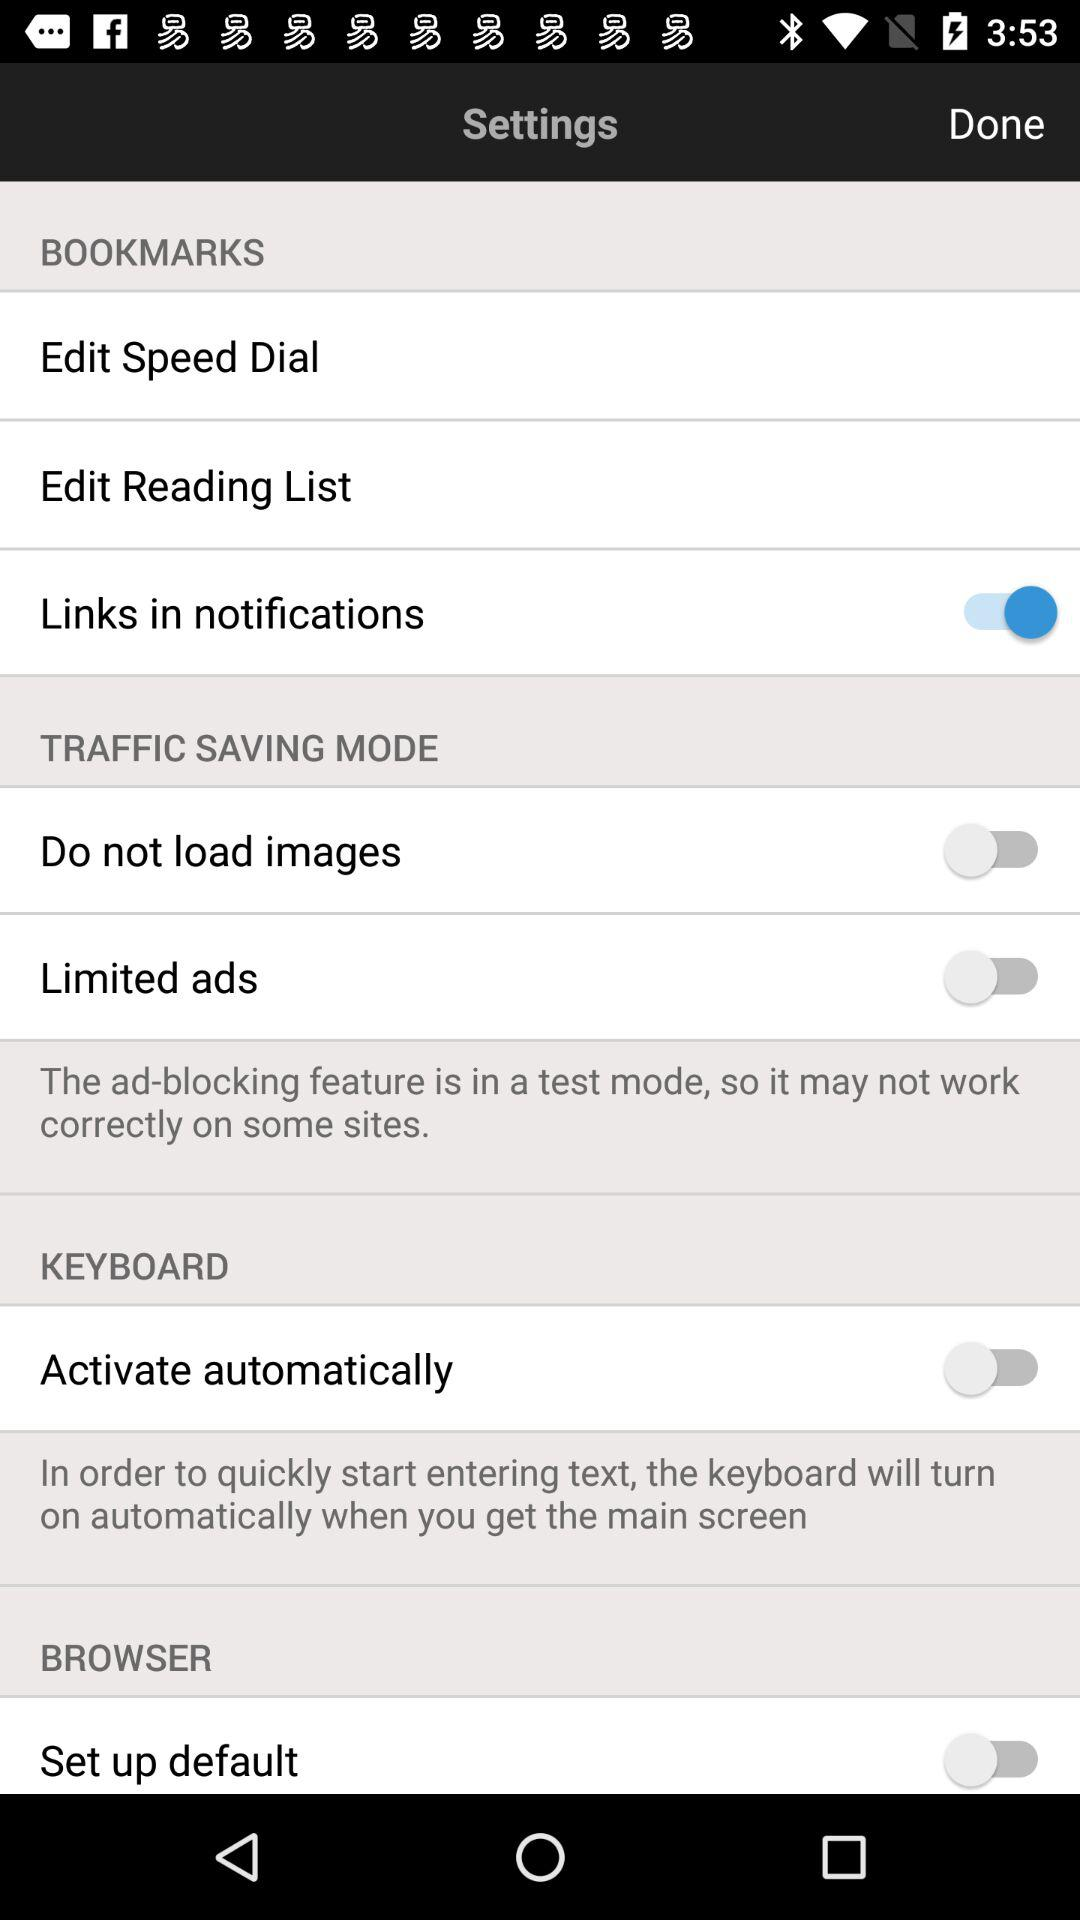What is the current status of the "Limited ads"? The current status of the "Limited ads" is "off". 